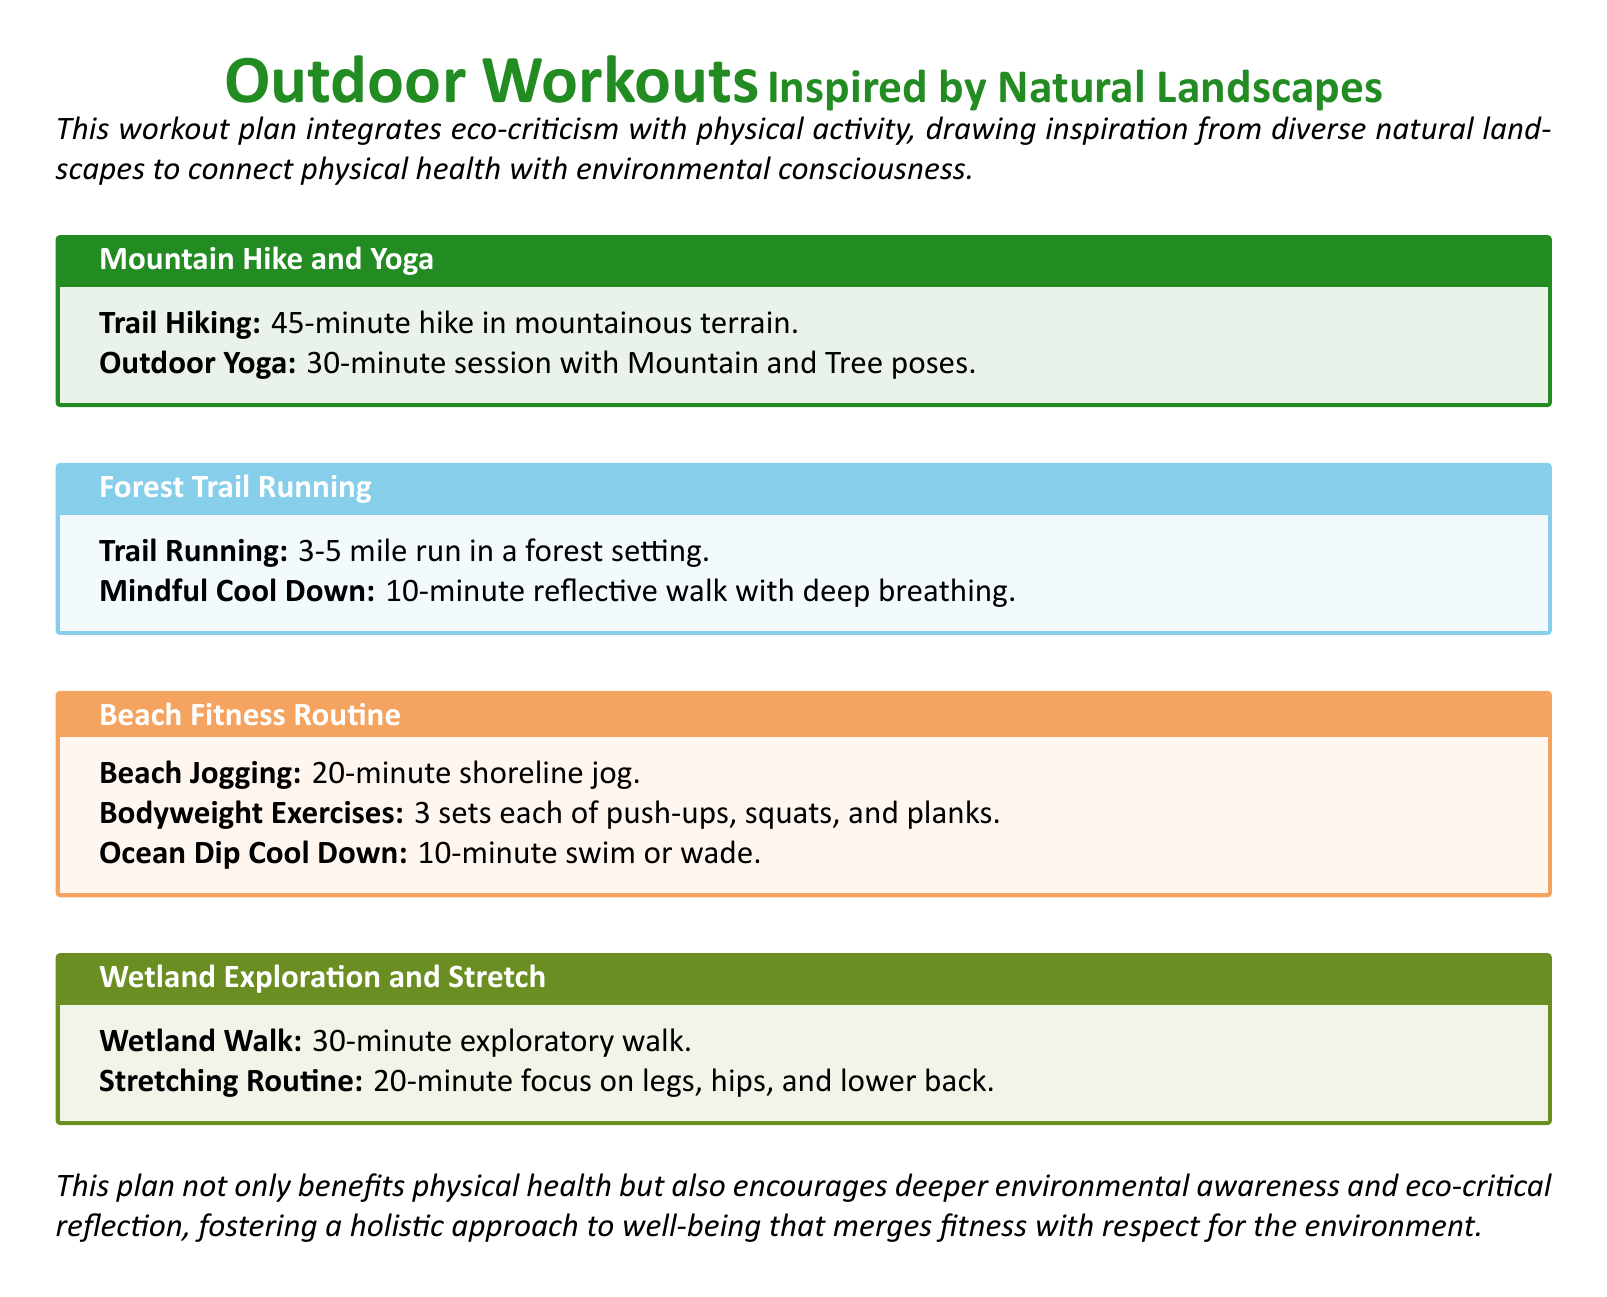What is the title of the workout plan? The title is prominently displayed at the top of the document.
Answer: Outdoor Workouts Inspired by Natural Landscapes How long is the mountain hike in the first workout? The duration for the mountain hike is specified in minutes in the workout box.
Answer: 45-minute What type of exercise is included in the Beach Fitness Routine? The Beach Fitness Routine includes specific activities outlined in the workout box.
Answer: Bodyweight Exercises How long is the reflective cool-down after trail running? The cool-down time is noted in minutes in the workout box.
Answer: 10-minute What color is used for the section title of Forest Trail Running? The color for the section title is defined in the document.
Answer: Skyblue What is the purpose of this workout plan besides physical health? The document mentions an additional aspect associated with the workout plan.
Answer: Environmental awareness How many sets of bodyweight exercises are suggested in the Beach Fitness Routine? The document specifies the number of sets for the exercises in that section.
Answer: 3 sets Which natural landscape is associated with the Wetland Exploration and Stretch? Each workout is linked to a specific natural setting as listed in the document.
Answer: Wetland 